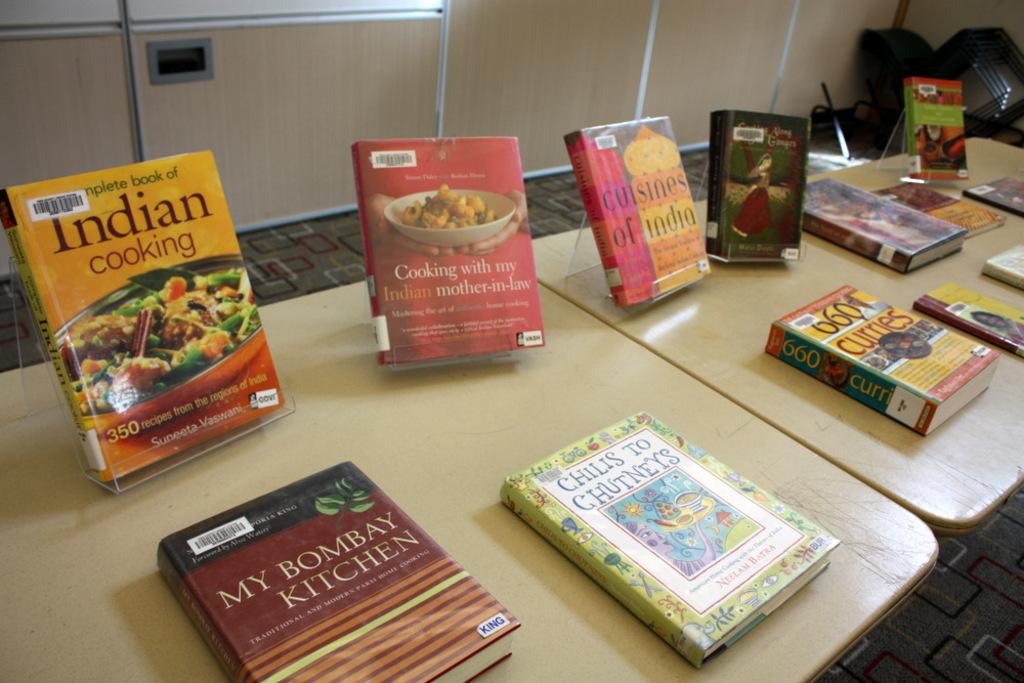Why type of cooking is the book on the left?
Make the answer very short. Indian cooking. How many curries can you find in the book on the table?
Offer a terse response. 660. 